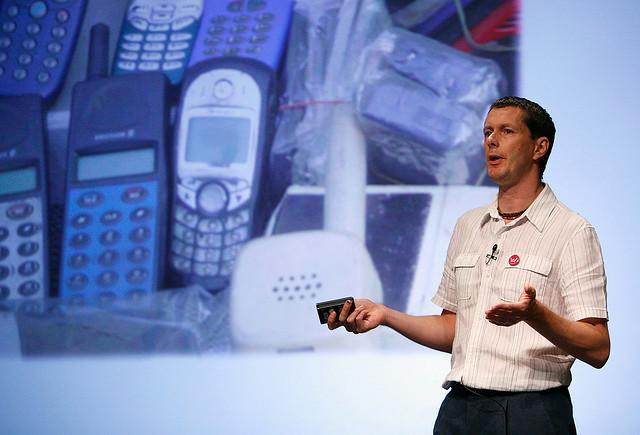What is the subject of the speech being given?

Choices:
A) candy
B) cell phones
C) animal husbandry
D) womens rights cell phones 